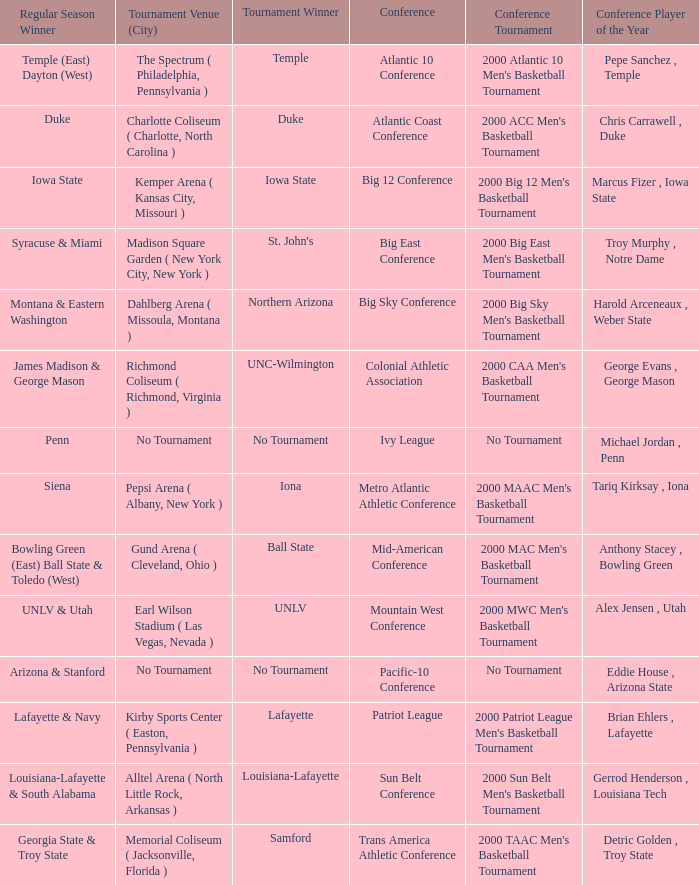How many players of the year are there in the Mountain West Conference? 1.0. 